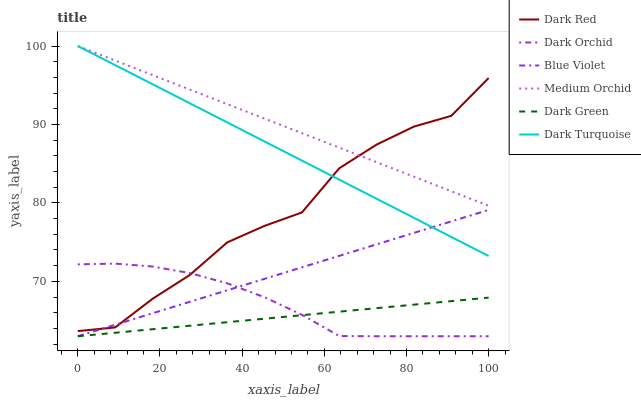Does Dark Green have the minimum area under the curve?
Answer yes or no. Yes. Does Dark Orchid have the minimum area under the curve?
Answer yes or no. No. Does Dark Orchid have the maximum area under the curve?
Answer yes or no. No. Is Dark Red the roughest?
Answer yes or no. Yes. Is Medium Orchid the smoothest?
Answer yes or no. No. Is Medium Orchid the roughest?
Answer yes or no. No. Does Medium Orchid have the lowest value?
Answer yes or no. No. Does Dark Orchid have the highest value?
Answer yes or no. No. Is Dark Green less than Medium Orchid?
Answer yes or no. Yes. Is Dark Red greater than Dark Green?
Answer yes or no. Yes. Does Dark Green intersect Medium Orchid?
Answer yes or no. No. 